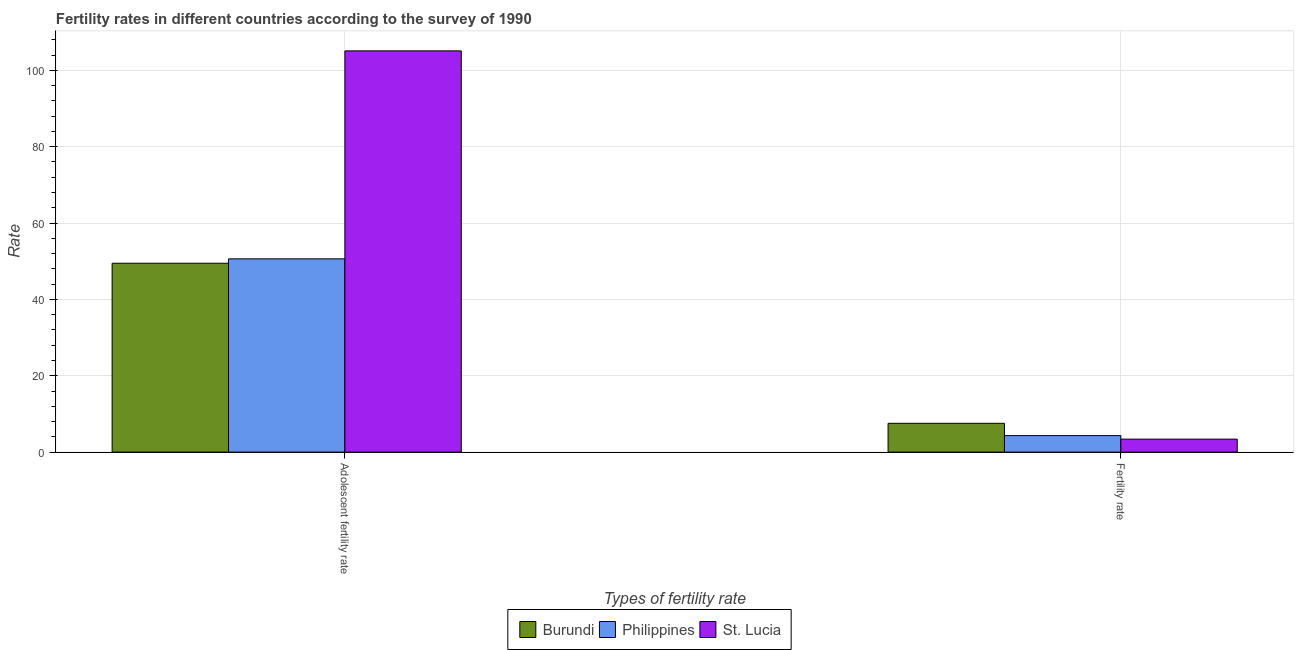How many different coloured bars are there?
Offer a very short reply. 3. How many groups of bars are there?
Keep it short and to the point. 2. Are the number of bars per tick equal to the number of legend labels?
Provide a succinct answer. Yes. How many bars are there on the 1st tick from the left?
Offer a terse response. 3. What is the label of the 2nd group of bars from the left?
Ensure brevity in your answer.  Fertility rate. What is the fertility rate in Philippines?
Your answer should be compact. 4.32. Across all countries, what is the maximum fertility rate?
Provide a succinct answer. 7.54. Across all countries, what is the minimum fertility rate?
Offer a terse response. 3.4. In which country was the adolescent fertility rate maximum?
Your answer should be compact. St. Lucia. In which country was the adolescent fertility rate minimum?
Offer a very short reply. Burundi. What is the total adolescent fertility rate in the graph?
Offer a terse response. 205.18. What is the difference between the fertility rate in Philippines and that in St. Lucia?
Your answer should be compact. 0.92. What is the difference between the fertility rate in St. Lucia and the adolescent fertility rate in Philippines?
Provide a short and direct response. -47.22. What is the average adolescent fertility rate per country?
Ensure brevity in your answer.  68.39. What is the difference between the fertility rate and adolescent fertility rate in Burundi?
Offer a terse response. -41.93. What is the ratio of the adolescent fertility rate in Burundi to that in Philippines?
Offer a very short reply. 0.98. In how many countries, is the adolescent fertility rate greater than the average adolescent fertility rate taken over all countries?
Offer a terse response. 1. What does the 3rd bar from the left in Adolescent fertility rate represents?
Provide a succinct answer. St. Lucia. What does the 3rd bar from the right in Adolescent fertility rate represents?
Keep it short and to the point. Burundi. What is the difference between two consecutive major ticks on the Y-axis?
Your answer should be very brief. 20. Does the graph contain any zero values?
Provide a succinct answer. No. Does the graph contain grids?
Keep it short and to the point. Yes. How many legend labels are there?
Your answer should be very brief. 3. How are the legend labels stacked?
Ensure brevity in your answer.  Horizontal. What is the title of the graph?
Keep it short and to the point. Fertility rates in different countries according to the survey of 1990. What is the label or title of the X-axis?
Provide a succinct answer. Types of fertility rate. What is the label or title of the Y-axis?
Make the answer very short. Rate. What is the Rate in Burundi in Adolescent fertility rate?
Provide a short and direct response. 49.47. What is the Rate in Philippines in Adolescent fertility rate?
Your response must be concise. 50.62. What is the Rate of St. Lucia in Adolescent fertility rate?
Keep it short and to the point. 105.09. What is the Rate of Burundi in Fertility rate?
Provide a succinct answer. 7.54. What is the Rate of Philippines in Fertility rate?
Keep it short and to the point. 4.32. What is the Rate in St. Lucia in Fertility rate?
Provide a succinct answer. 3.4. Across all Types of fertility rate, what is the maximum Rate of Burundi?
Offer a terse response. 49.47. Across all Types of fertility rate, what is the maximum Rate of Philippines?
Ensure brevity in your answer.  50.62. Across all Types of fertility rate, what is the maximum Rate in St. Lucia?
Offer a very short reply. 105.09. Across all Types of fertility rate, what is the minimum Rate of Burundi?
Offer a very short reply. 7.54. Across all Types of fertility rate, what is the minimum Rate of Philippines?
Make the answer very short. 4.32. Across all Types of fertility rate, what is the minimum Rate of St. Lucia?
Your answer should be very brief. 3.4. What is the total Rate of Burundi in the graph?
Provide a short and direct response. 57.01. What is the total Rate of Philippines in the graph?
Make the answer very short. 54.94. What is the total Rate in St. Lucia in the graph?
Offer a terse response. 108.49. What is the difference between the Rate in Burundi in Adolescent fertility rate and that in Fertility rate?
Your answer should be compact. 41.93. What is the difference between the Rate in Philippines in Adolescent fertility rate and that in Fertility rate?
Your answer should be compact. 46.3. What is the difference between the Rate of St. Lucia in Adolescent fertility rate and that in Fertility rate?
Provide a succinct answer. 101.7. What is the difference between the Rate in Burundi in Adolescent fertility rate and the Rate in Philippines in Fertility rate?
Keep it short and to the point. 45.15. What is the difference between the Rate in Burundi in Adolescent fertility rate and the Rate in St. Lucia in Fertility rate?
Provide a succinct answer. 46.07. What is the difference between the Rate of Philippines in Adolescent fertility rate and the Rate of St. Lucia in Fertility rate?
Make the answer very short. 47.22. What is the average Rate in Burundi per Types of fertility rate?
Your answer should be compact. 28.51. What is the average Rate in Philippines per Types of fertility rate?
Your answer should be very brief. 27.47. What is the average Rate of St. Lucia per Types of fertility rate?
Provide a short and direct response. 54.25. What is the difference between the Rate of Burundi and Rate of Philippines in Adolescent fertility rate?
Provide a succinct answer. -1.15. What is the difference between the Rate of Burundi and Rate of St. Lucia in Adolescent fertility rate?
Offer a terse response. -55.62. What is the difference between the Rate of Philippines and Rate of St. Lucia in Adolescent fertility rate?
Give a very brief answer. -54.47. What is the difference between the Rate of Burundi and Rate of Philippines in Fertility rate?
Provide a short and direct response. 3.22. What is the difference between the Rate in Burundi and Rate in St. Lucia in Fertility rate?
Provide a succinct answer. 4.14. What is the difference between the Rate of Philippines and Rate of St. Lucia in Fertility rate?
Your response must be concise. 0.92. What is the ratio of the Rate of Burundi in Adolescent fertility rate to that in Fertility rate?
Your answer should be very brief. 6.56. What is the ratio of the Rate in Philippines in Adolescent fertility rate to that in Fertility rate?
Your answer should be compact. 11.72. What is the ratio of the Rate of St. Lucia in Adolescent fertility rate to that in Fertility rate?
Provide a succinct answer. 30.93. What is the difference between the highest and the second highest Rate in Burundi?
Give a very brief answer. 41.93. What is the difference between the highest and the second highest Rate in Philippines?
Your answer should be very brief. 46.3. What is the difference between the highest and the second highest Rate in St. Lucia?
Keep it short and to the point. 101.7. What is the difference between the highest and the lowest Rate in Burundi?
Provide a succinct answer. 41.93. What is the difference between the highest and the lowest Rate of Philippines?
Offer a very short reply. 46.3. What is the difference between the highest and the lowest Rate in St. Lucia?
Provide a succinct answer. 101.7. 